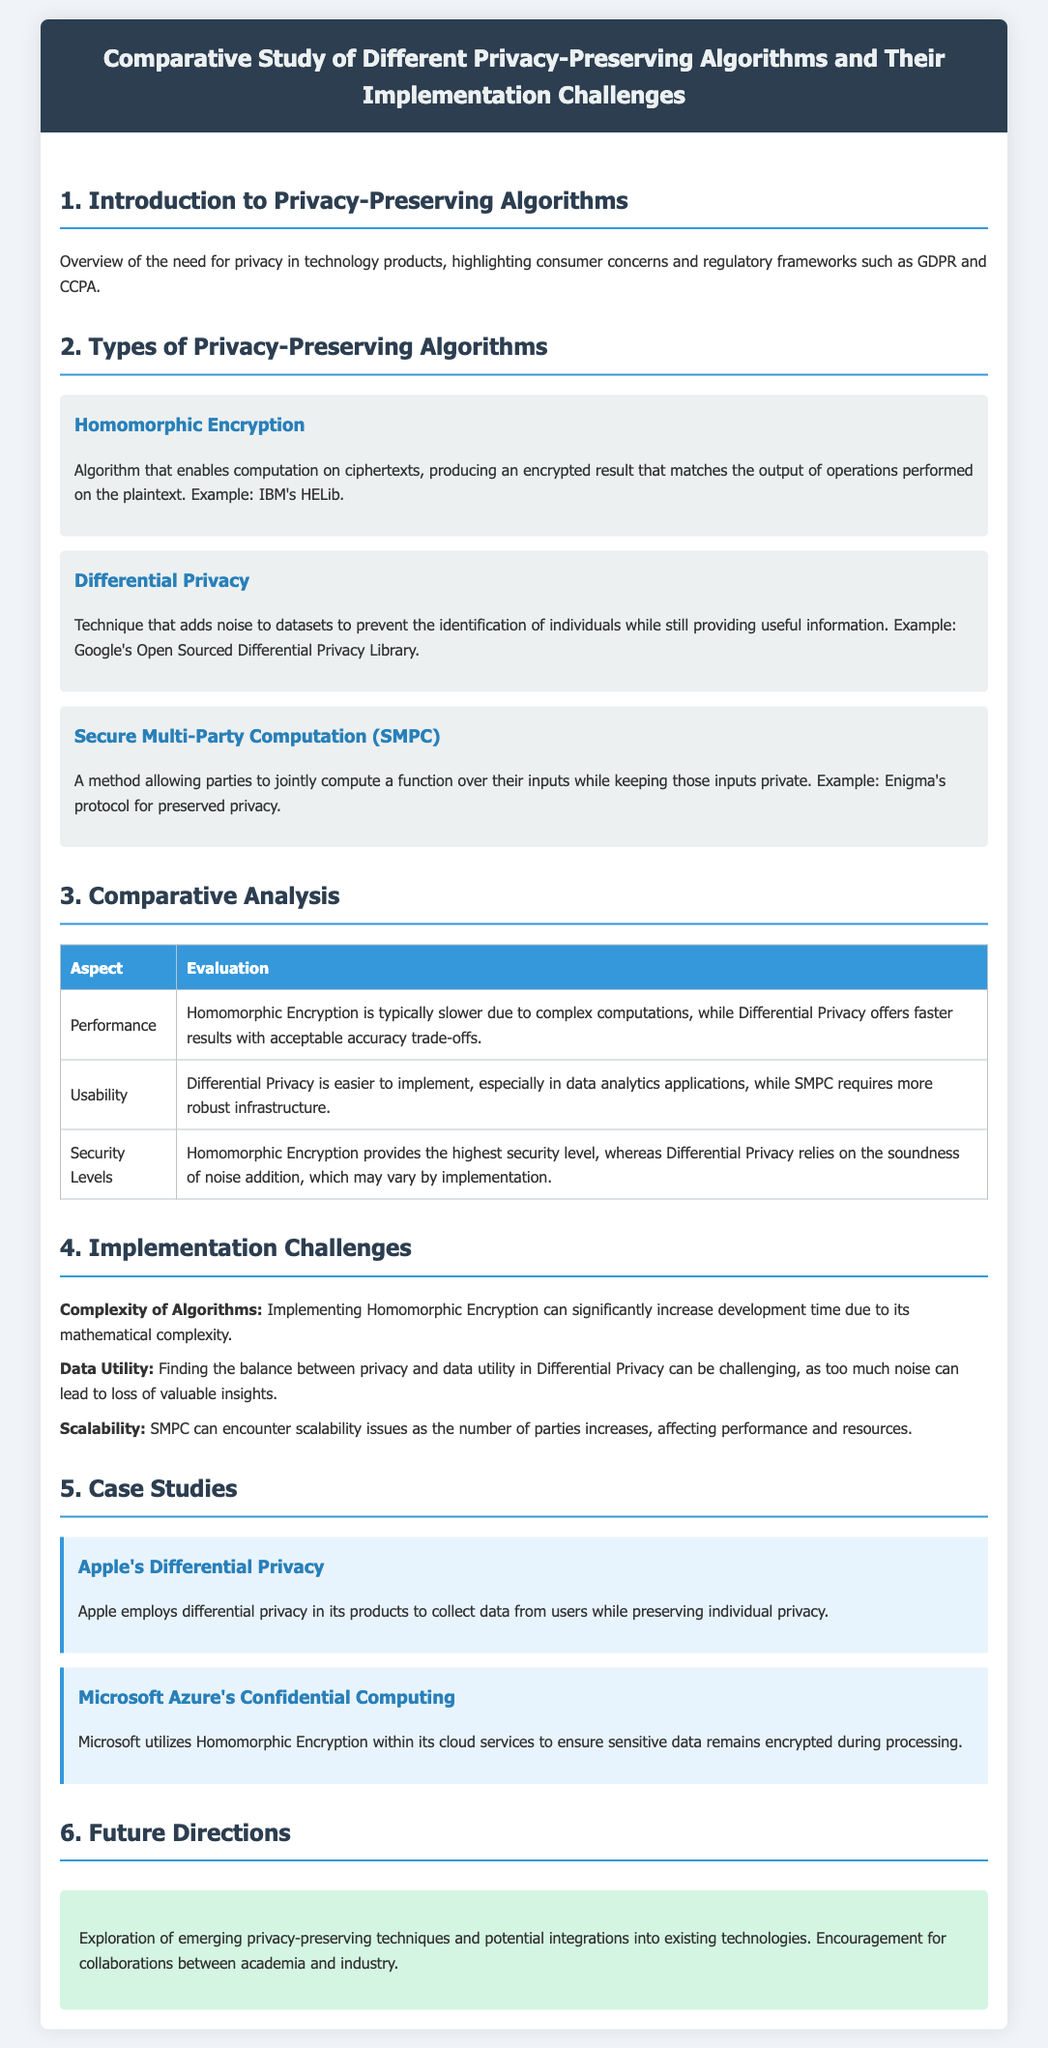what is the title of the document? The title is located in the header of the document.
Answer: Comparative Study of Different Privacy-Preserving Algorithms and Their Implementation Challenges what algorithm enables computation on ciphertexts? The document mentions a specific algorithm that allows computations on encrypted data.
Answer: Homomorphic Encryption which company uses differential privacy in its products? This question looks for the name of the company that implements a specific privacy technique.
Answer: Apple what aspect is evaluated in terms of performance? The document lists various aspects evaluated in the comparative analysis section.
Answer: Performance what is one challenge of implementing differential privacy? The document outlines various implementation challenges related to privacy-preserving algorithms.
Answer: Data Utility how many case studies are mentioned? A count of specific case studies included in the document can be found in the case studies section.
Answer: 2 which privacy-preserving technique typically requires more infrastructure? The document describes the requirements of different privacy-preserving techniques based on usability.
Answer: SMPC what is a future direction mentioned in the document? The last section summarizes the anticipated developments in privacy-preserving technologies.
Answer: Collaborations between academia and industry 